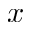Convert formula to latex. <formula><loc_0><loc_0><loc_500><loc_500>x</formula> 